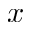Convert formula to latex. <formula><loc_0><loc_0><loc_500><loc_500>x</formula> 